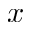Convert formula to latex. <formula><loc_0><loc_0><loc_500><loc_500>x</formula> 